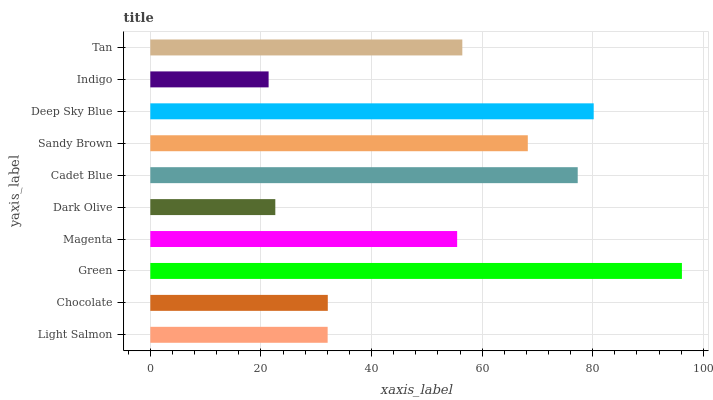Is Indigo the minimum?
Answer yes or no. Yes. Is Green the maximum?
Answer yes or no. Yes. Is Chocolate the minimum?
Answer yes or no. No. Is Chocolate the maximum?
Answer yes or no. No. Is Chocolate greater than Light Salmon?
Answer yes or no. Yes. Is Light Salmon less than Chocolate?
Answer yes or no. Yes. Is Light Salmon greater than Chocolate?
Answer yes or no. No. Is Chocolate less than Light Salmon?
Answer yes or no. No. Is Tan the high median?
Answer yes or no. Yes. Is Magenta the low median?
Answer yes or no. Yes. Is Chocolate the high median?
Answer yes or no. No. Is Dark Olive the low median?
Answer yes or no. No. 